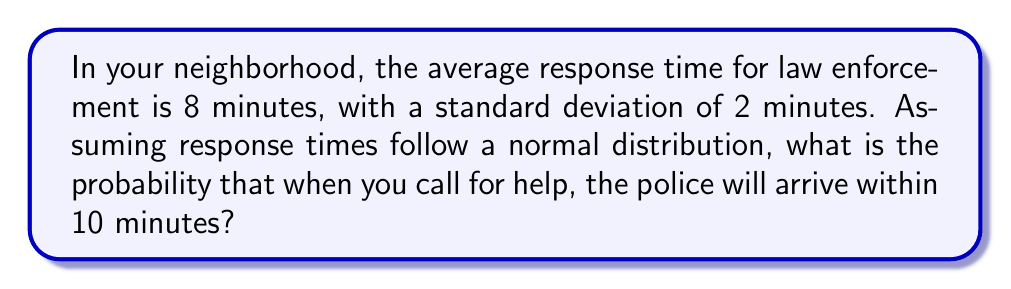What is the answer to this math problem? To solve this problem, we'll use the properties of the normal distribution and the concept of z-scores.

Step 1: Identify the given information
- Mean response time (μ) = 8 minutes
- Standard deviation (σ) = 2 minutes
- Desired response time (x) = 10 minutes

Step 2: Calculate the z-score
The z-score represents how many standard deviations the desired time is from the mean.

$$ z = \frac{x - \mu}{\sigma} = \frac{10 - 8}{2} = 1 $$

Step 3: Use the standard normal distribution table or calculator
For z = 1, the area under the curve to the left of z is approximately 0.8413.

Step 4: Interpret the result
The area under the curve represents the probability of the police arriving within 10 minutes or less.

Therefore, the probability of the police arriving within 10 minutes is 0.8413 or about 84.13%.
Answer: 0.8413 or 84.13% 